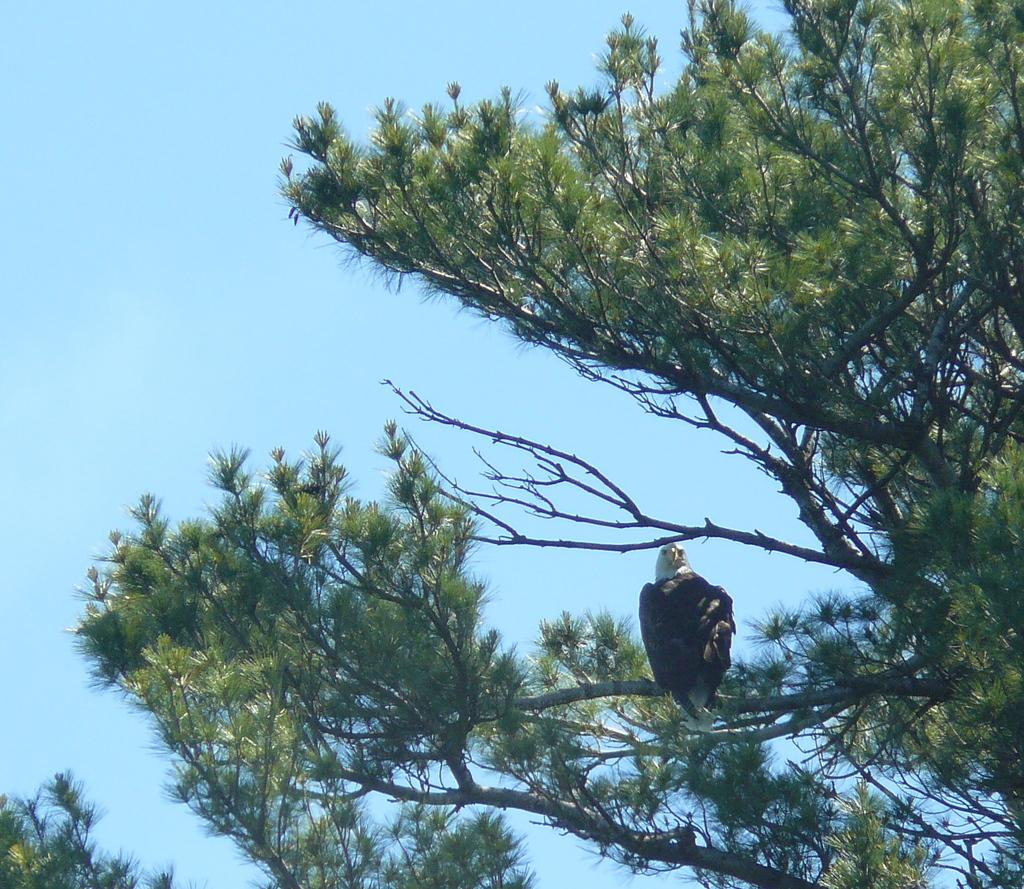What type of animal can be seen in the image? There is a bird in the image. Where is the bird located? The bird is on a branch of a tree. What can be seen in the background of the image? The sky is visible in the background of the image. What is the rate at which the snails are moving in the image? There are no snails present in the image, so it is not possible to determine their rate of movement. 